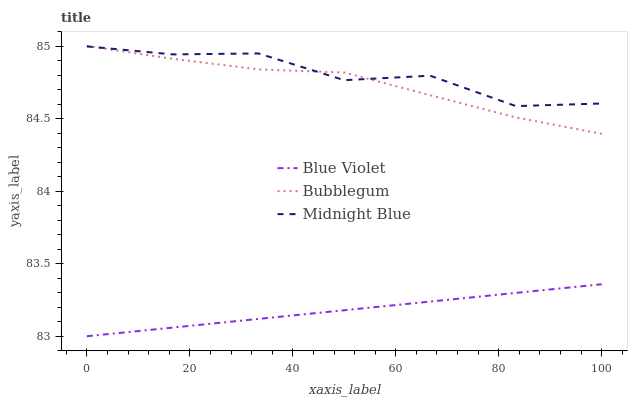Does Blue Violet have the minimum area under the curve?
Answer yes or no. Yes. Does Midnight Blue have the maximum area under the curve?
Answer yes or no. Yes. Does Midnight Blue have the minimum area under the curve?
Answer yes or no. No. Does Blue Violet have the maximum area under the curve?
Answer yes or no. No. Is Blue Violet the smoothest?
Answer yes or no. Yes. Is Midnight Blue the roughest?
Answer yes or no. Yes. Is Midnight Blue the smoothest?
Answer yes or no. No. Is Blue Violet the roughest?
Answer yes or no. No. Does Blue Violet have the lowest value?
Answer yes or no. Yes. Does Midnight Blue have the lowest value?
Answer yes or no. No. Does Bubblegum have the highest value?
Answer yes or no. Yes. Does Midnight Blue have the highest value?
Answer yes or no. No. Is Blue Violet less than Midnight Blue?
Answer yes or no. Yes. Is Bubblegum greater than Blue Violet?
Answer yes or no. Yes. Does Midnight Blue intersect Bubblegum?
Answer yes or no. Yes. Is Midnight Blue less than Bubblegum?
Answer yes or no. No. Is Midnight Blue greater than Bubblegum?
Answer yes or no. No. Does Blue Violet intersect Midnight Blue?
Answer yes or no. No. 